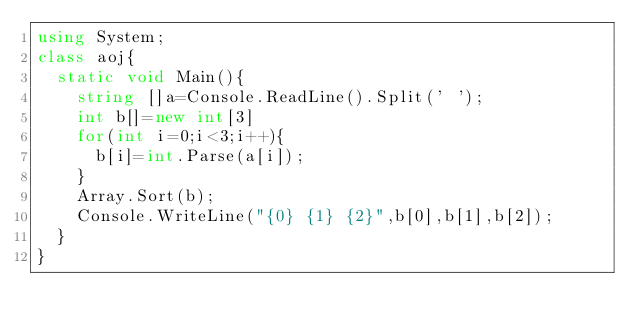Convert code to text. <code><loc_0><loc_0><loc_500><loc_500><_C#_>using System;
class aoj{
	static void Main(){
		string []a=Console.ReadLine().Split(' ');
		int b[]=new int[3]
		for(int i=0;i<3;i++){
			b[i]=int.Parse(a[i]);
		}
		Array.Sort(b);
		Console.WriteLine("{0} {1} {2}",b[0],b[1],b[2]);
	}
}</code> 